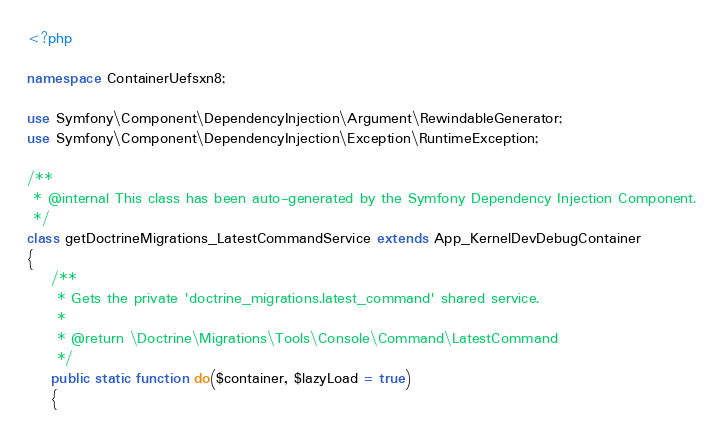Convert code to text. <code><loc_0><loc_0><loc_500><loc_500><_PHP_><?php

namespace ContainerUefsxn8;

use Symfony\Component\DependencyInjection\Argument\RewindableGenerator;
use Symfony\Component\DependencyInjection\Exception\RuntimeException;

/**
 * @internal This class has been auto-generated by the Symfony Dependency Injection Component.
 */
class getDoctrineMigrations_LatestCommandService extends App_KernelDevDebugContainer
{
    /**
     * Gets the private 'doctrine_migrations.latest_command' shared service.
     *
     * @return \Doctrine\Migrations\Tools\Console\Command\LatestCommand
     */
    public static function do($container, $lazyLoad = true)
    {</code> 